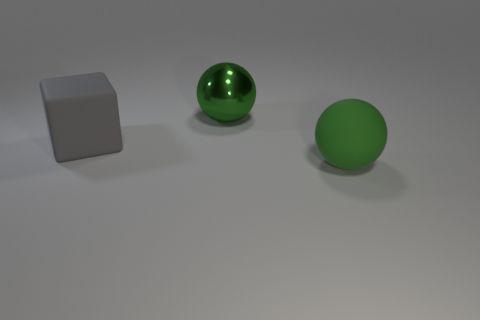Add 2 small yellow rubber spheres. How many objects exist? 5 Subtract all balls. How many objects are left? 1 Subtract 0 yellow blocks. How many objects are left? 3 Subtract all big gray rubber cubes. Subtract all gray shiny balls. How many objects are left? 2 Add 2 large gray matte things. How many large gray matte things are left? 3 Add 1 yellow matte spheres. How many yellow matte spheres exist? 1 